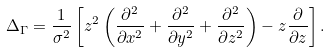<formula> <loc_0><loc_0><loc_500><loc_500>\Delta _ { \Gamma } = \frac { 1 } { \sigma ^ { 2 } } \left [ z ^ { 2 } \left ( \frac { \partial ^ { 2 } } { \partial x ^ { 2 } } + \frac { \partial ^ { 2 } } { \partial y ^ { 2 } } + \frac { \partial ^ { 2 } } { \partial z ^ { 2 } } \right ) - z \frac { \partial } { \partial z } \right ] .</formula> 